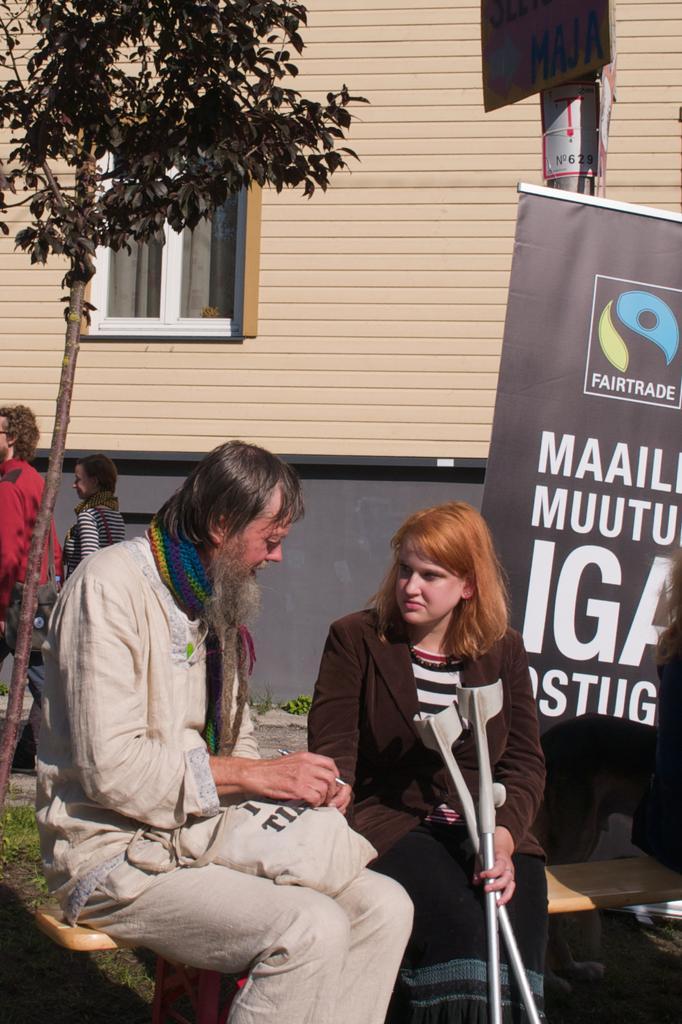Describe this image in one or two sentences. In this picture there is a man who is sitting on the bench, beside him there is a woman who is holding the sticks. On the right there is a banner. On the left there are two persons were standing near to the trees and building. In the top left corner there is a window and in the top right there is an electric pole. 